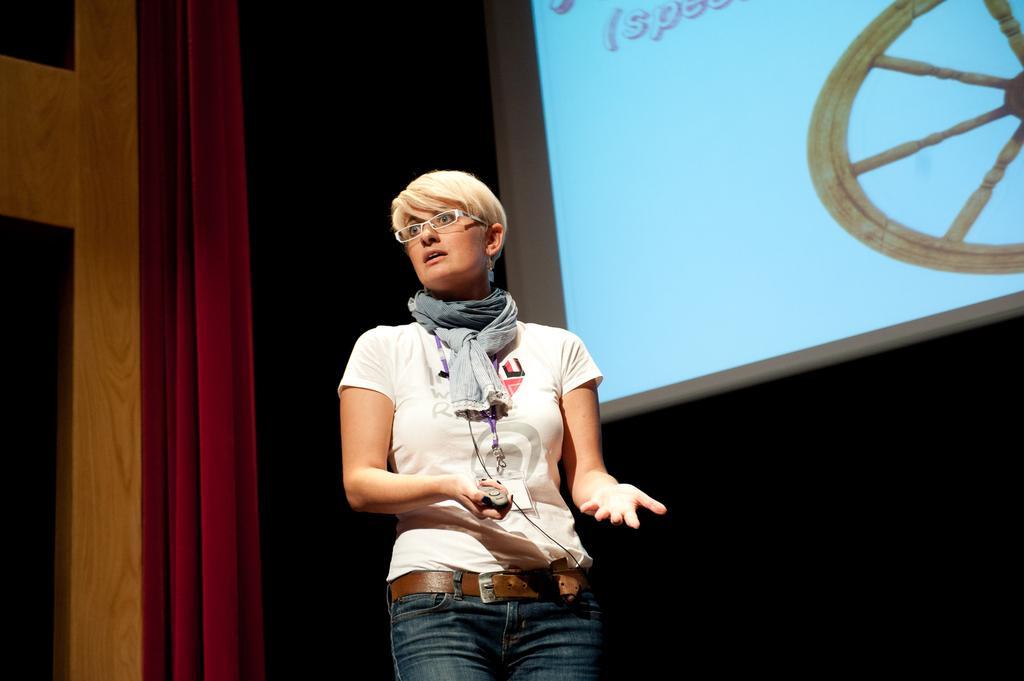Describe this image in one or two sentences. In this picture we can see a woman,she is standing on the stage and in the background we can see a screen,red color curtain. 